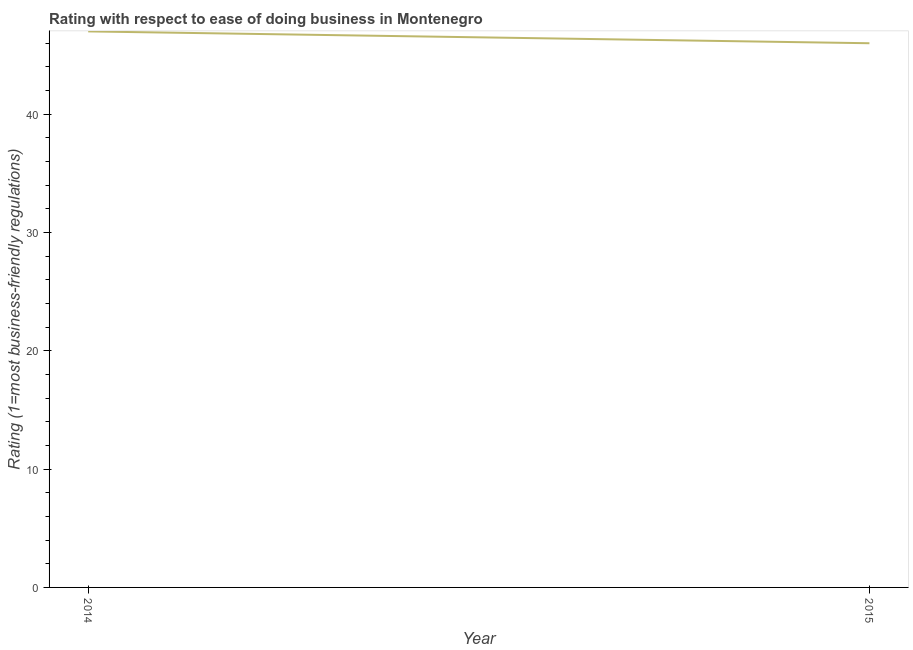What is the ease of doing business index in 2014?
Keep it short and to the point. 47. Across all years, what is the maximum ease of doing business index?
Your response must be concise. 47. Across all years, what is the minimum ease of doing business index?
Your answer should be very brief. 46. In which year was the ease of doing business index maximum?
Give a very brief answer. 2014. In which year was the ease of doing business index minimum?
Give a very brief answer. 2015. What is the sum of the ease of doing business index?
Ensure brevity in your answer.  93. What is the difference between the ease of doing business index in 2014 and 2015?
Your response must be concise. 1. What is the average ease of doing business index per year?
Offer a very short reply. 46.5. What is the median ease of doing business index?
Make the answer very short. 46.5. In how many years, is the ease of doing business index greater than 14 ?
Make the answer very short. 2. Do a majority of the years between 2015 and 2014 (inclusive) have ease of doing business index greater than 32 ?
Ensure brevity in your answer.  No. What is the ratio of the ease of doing business index in 2014 to that in 2015?
Give a very brief answer. 1.02. In how many years, is the ease of doing business index greater than the average ease of doing business index taken over all years?
Your answer should be compact. 1. How many lines are there?
Your answer should be very brief. 1. How many years are there in the graph?
Your answer should be very brief. 2. What is the difference between two consecutive major ticks on the Y-axis?
Offer a very short reply. 10. Are the values on the major ticks of Y-axis written in scientific E-notation?
Your response must be concise. No. Does the graph contain any zero values?
Your response must be concise. No. Does the graph contain grids?
Keep it short and to the point. No. What is the title of the graph?
Make the answer very short. Rating with respect to ease of doing business in Montenegro. What is the label or title of the X-axis?
Ensure brevity in your answer.  Year. What is the label or title of the Y-axis?
Provide a short and direct response. Rating (1=most business-friendly regulations). What is the Rating (1=most business-friendly regulations) of 2015?
Offer a terse response. 46. What is the ratio of the Rating (1=most business-friendly regulations) in 2014 to that in 2015?
Ensure brevity in your answer.  1.02. 